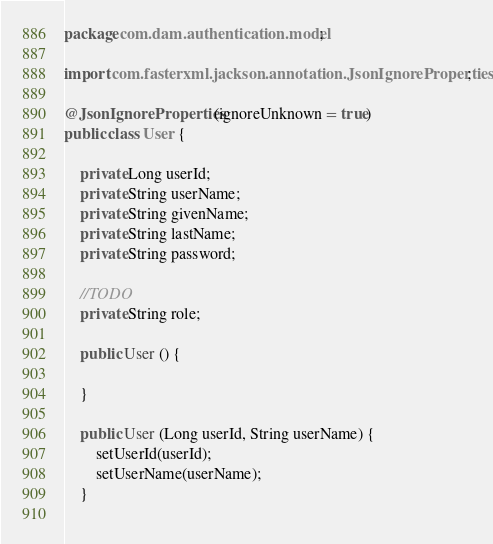<code> <loc_0><loc_0><loc_500><loc_500><_Java_>package com.dam.authentication.model;

import com.fasterxml.jackson.annotation.JsonIgnoreProperties;

@JsonIgnoreProperties(ignoreUnknown = true)
public class User {
	
	private Long userId;
	private String userName;
	private String givenName;
	private String lastName;
	private String password;
	
	//TODO
	private String role;
	
	public User () {
		
	}
	
	public User (Long userId, String userName) {
		setUserId(userId);
		setUserName(userName);
	}
	</code> 